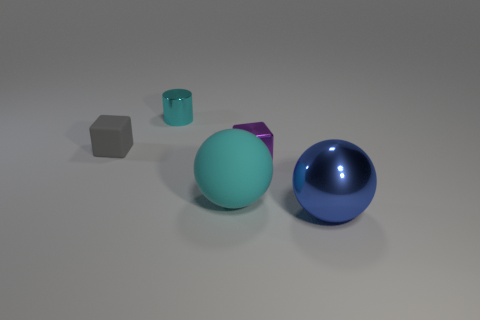Is there anything else that is the same shape as the tiny cyan object?
Provide a short and direct response. No. Does the matte object on the right side of the small gray matte block have the same size as the rubber thing behind the big cyan sphere?
Your answer should be compact. No. The ball that is behind the large object that is in front of the large cyan sphere that is left of the metallic cube is what color?
Your response must be concise. Cyan. Is there a purple thing that has the same shape as the small gray thing?
Your answer should be compact. Yes. Is the number of spheres behind the purple thing the same as the number of matte things in front of the big cyan rubber thing?
Provide a succinct answer. Yes. There is a large thing to the right of the tiny purple metal cube; is it the same shape as the large cyan object?
Offer a very short reply. Yes. Does the large cyan object have the same shape as the gray object?
Provide a short and direct response. No. What number of metallic objects are cyan objects or big blue balls?
Ensure brevity in your answer.  2. There is a big thing that is the same color as the cylinder; what is it made of?
Give a very brief answer. Rubber. Is the size of the cyan shiny thing the same as the gray matte object?
Provide a short and direct response. Yes. 